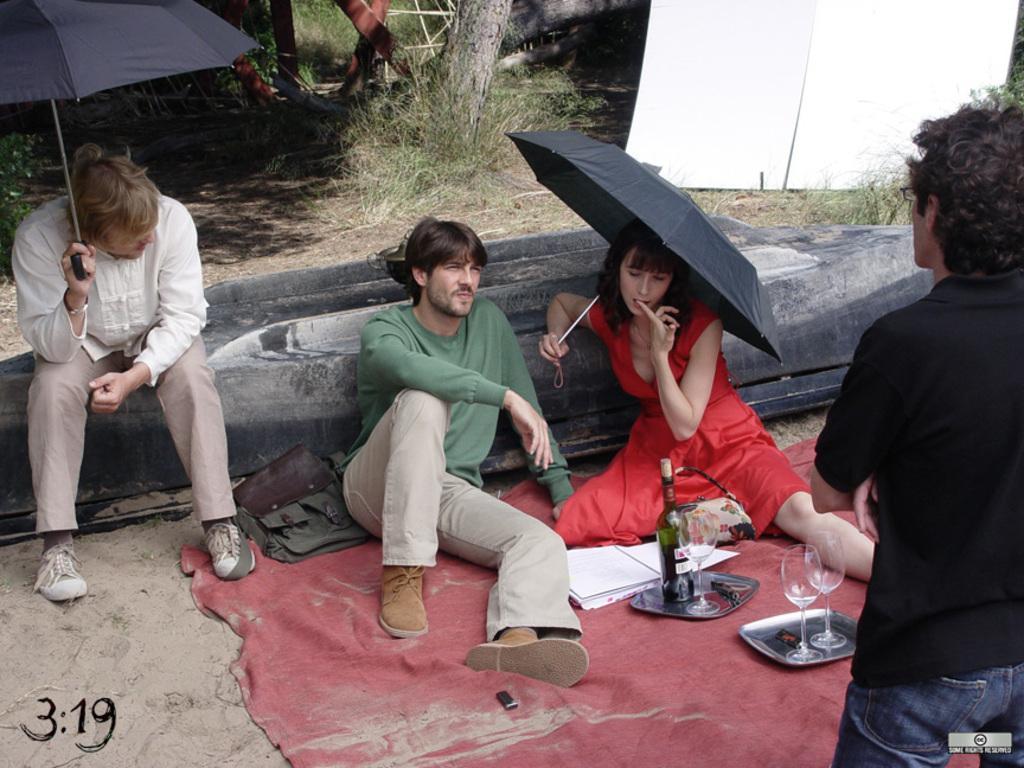Could you give a brief overview of what you see in this image? In this image I can see a person wearing black and blue colored dress is standing and I can see three persons are sitting. I can see few wine glasses, a bottle, few trays and few other objects on the ground. I can see a person is sitting on the boat which is inverted. In the background I can see few trees, a white colored board and few brown colored objects. 